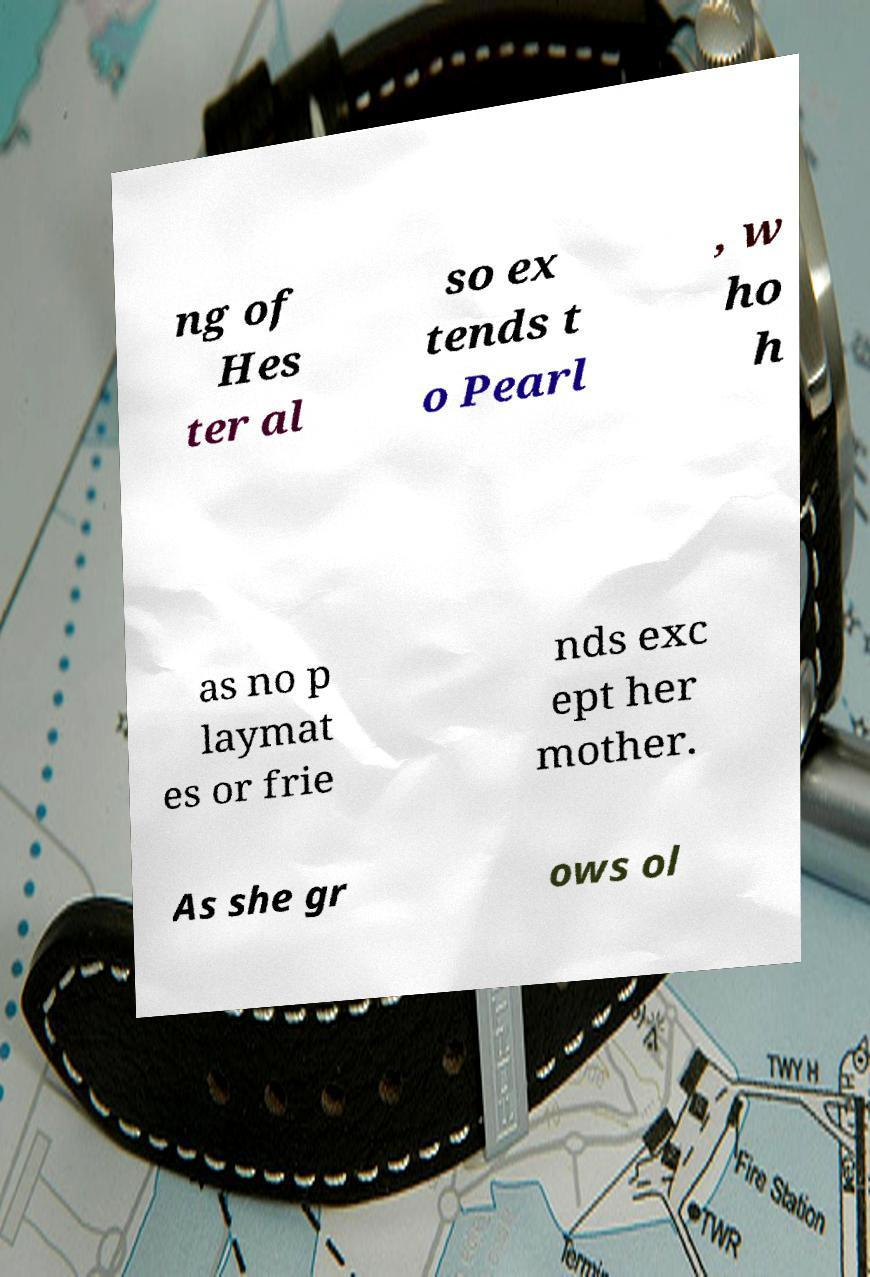I need the written content from this picture converted into text. Can you do that? ng of Hes ter al so ex tends t o Pearl , w ho h as no p laymat es or frie nds exc ept her mother. As she gr ows ol 